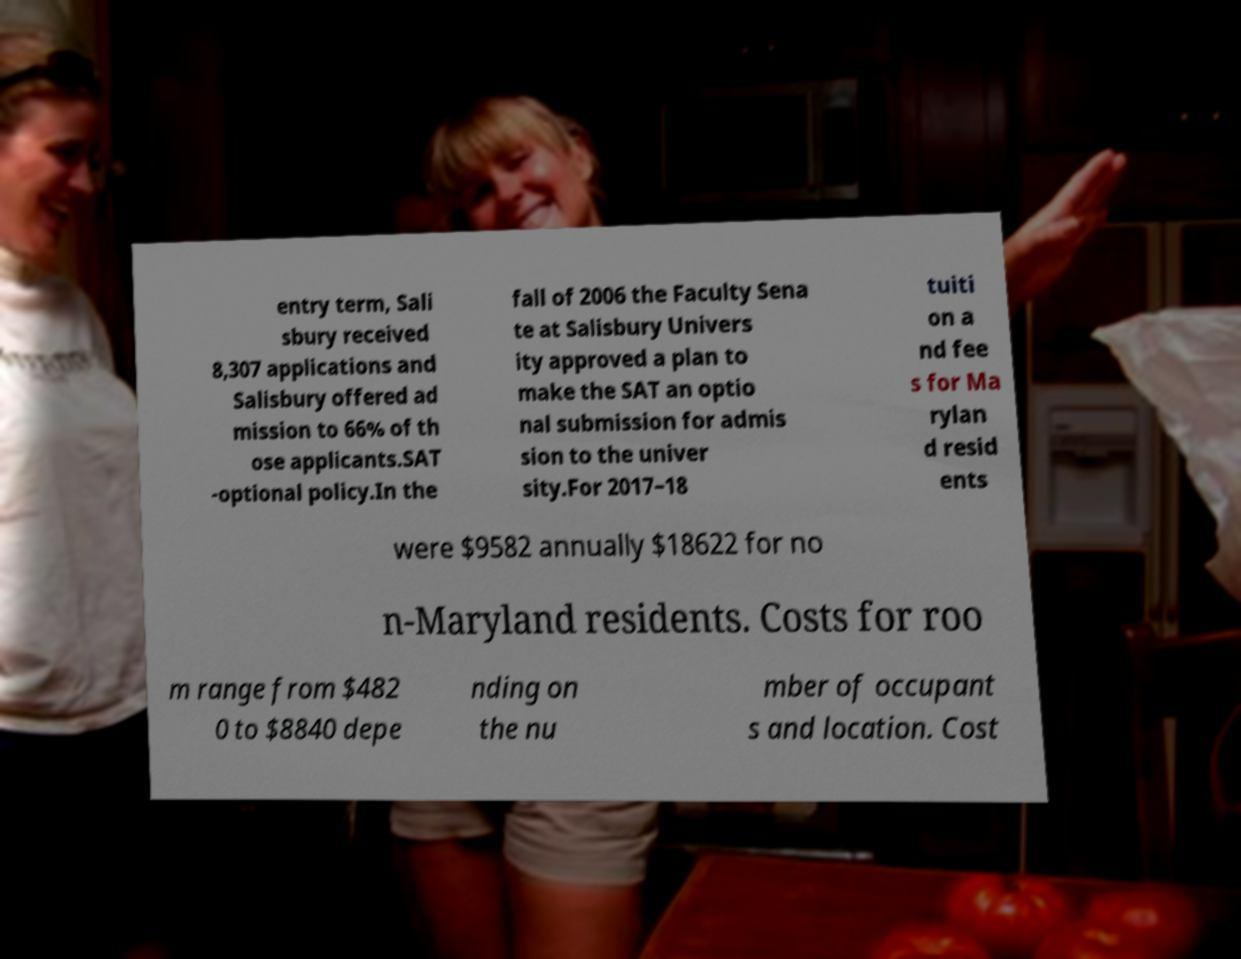There's text embedded in this image that I need extracted. Can you transcribe it verbatim? entry term, Sali sbury received 8,307 applications and Salisbury offered ad mission to 66% of th ose applicants.SAT -optional policy.In the fall of 2006 the Faculty Sena te at Salisbury Univers ity approved a plan to make the SAT an optio nal submission for admis sion to the univer sity.For 2017–18 tuiti on a nd fee s for Ma rylan d resid ents were $9582 annually $18622 for no n-Maryland residents. Costs for roo m range from $482 0 to $8840 depe nding on the nu mber of occupant s and location. Cost 